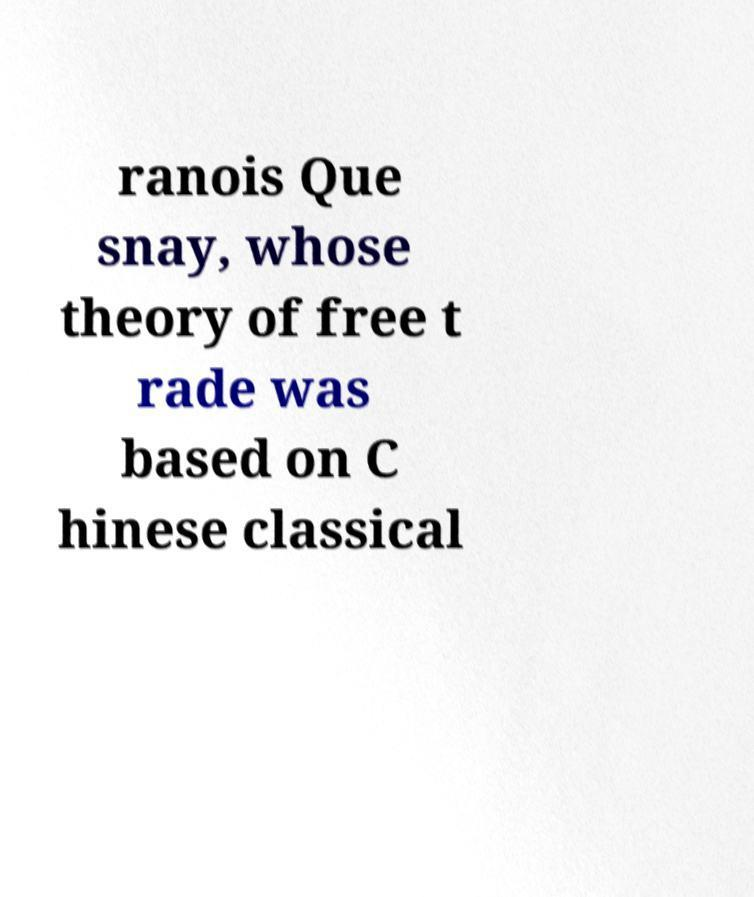Could you assist in decoding the text presented in this image and type it out clearly? ranois Que snay, whose theory of free t rade was based on C hinese classical 